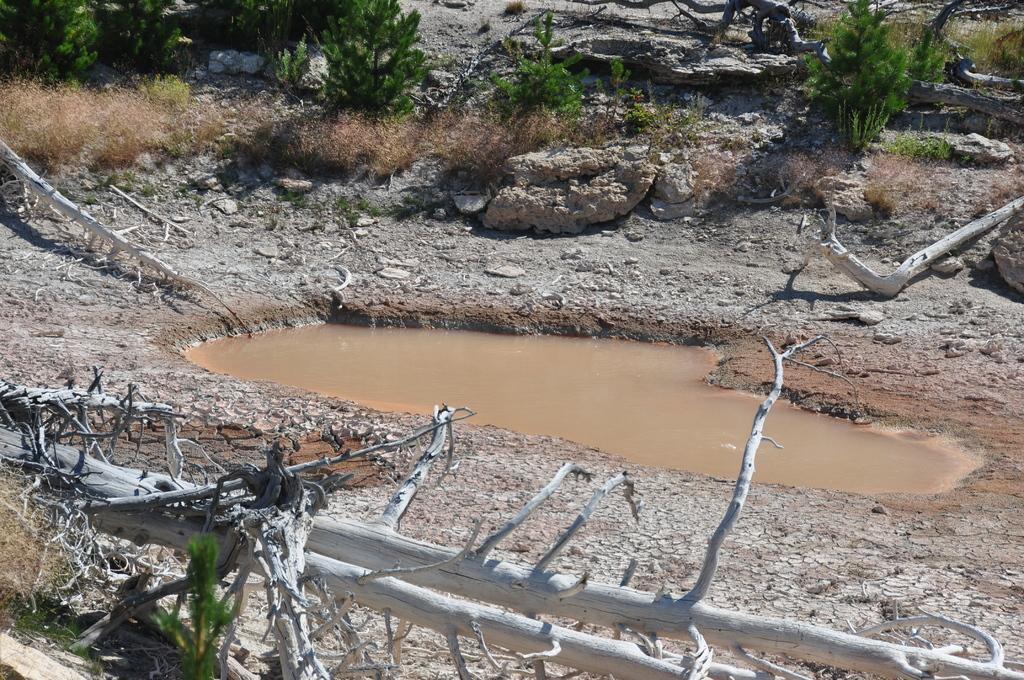What is the main feature in the middle of the image? There is a pond in the middle of the image. What can be seen around the pond? Land surrounds the pond. What is visible in the background of the image? There is a plant in the background of the image. What is the condition of the tree in the front of the image? A dried tree is present in the front of the image. What does the notebook smell like in the image? There is no notebook present in the image, so it cannot be determined what it might smell like. 